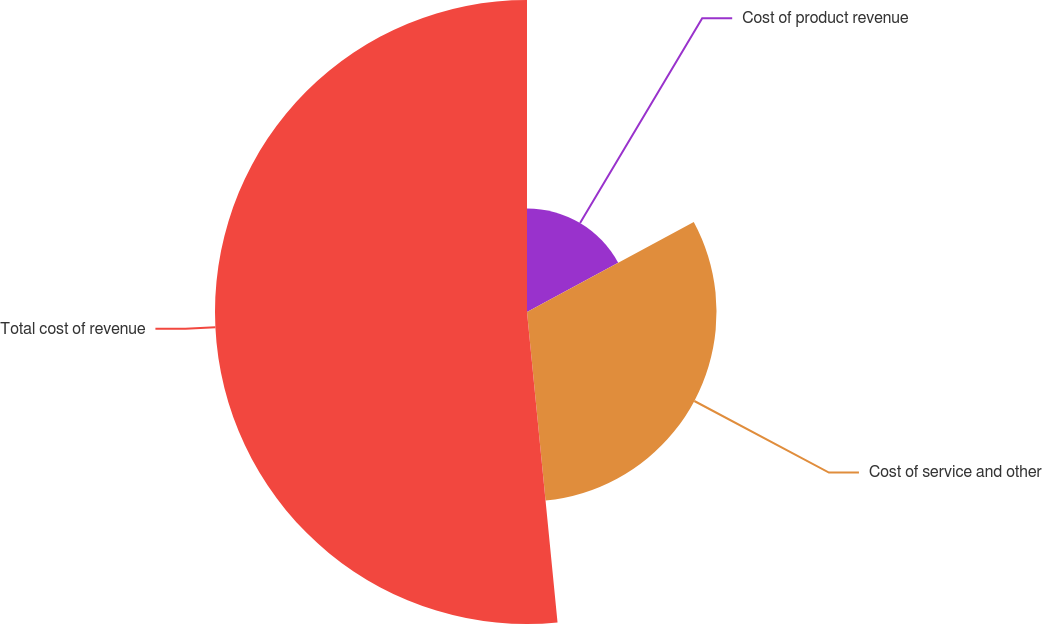Convert chart. <chart><loc_0><loc_0><loc_500><loc_500><pie_chart><fcel>Cost of product revenue<fcel>Cost of service and other<fcel>Total cost of revenue<nl><fcel>17.12%<fcel>31.32%<fcel>51.56%<nl></chart> 